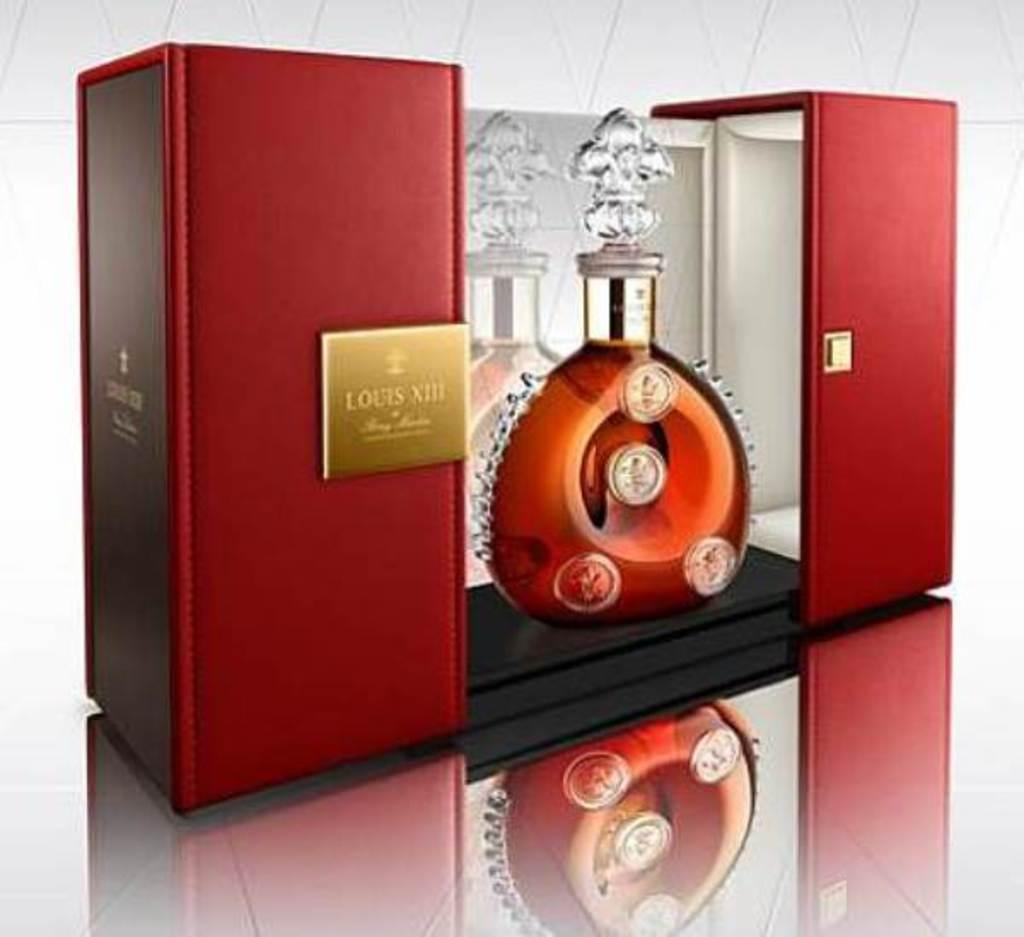<image>
Describe the image concisely. Glass decanter bottle of Louis VIII displayed within a beautiful red box. 